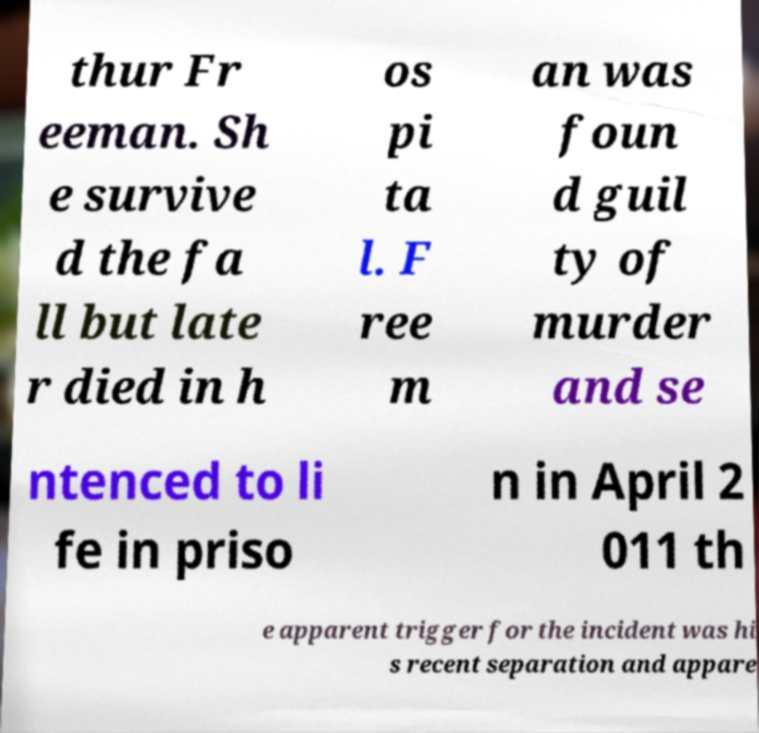Please identify and transcribe the text found in this image. thur Fr eeman. Sh e survive d the fa ll but late r died in h os pi ta l. F ree m an was foun d guil ty of murder and se ntenced to li fe in priso n in April 2 011 th e apparent trigger for the incident was hi s recent separation and appare 